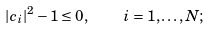<formula> <loc_0><loc_0><loc_500><loc_500>| c _ { i } | ^ { 2 } - 1 \leq 0 , \quad i = 1 , \dots , N ;</formula> 